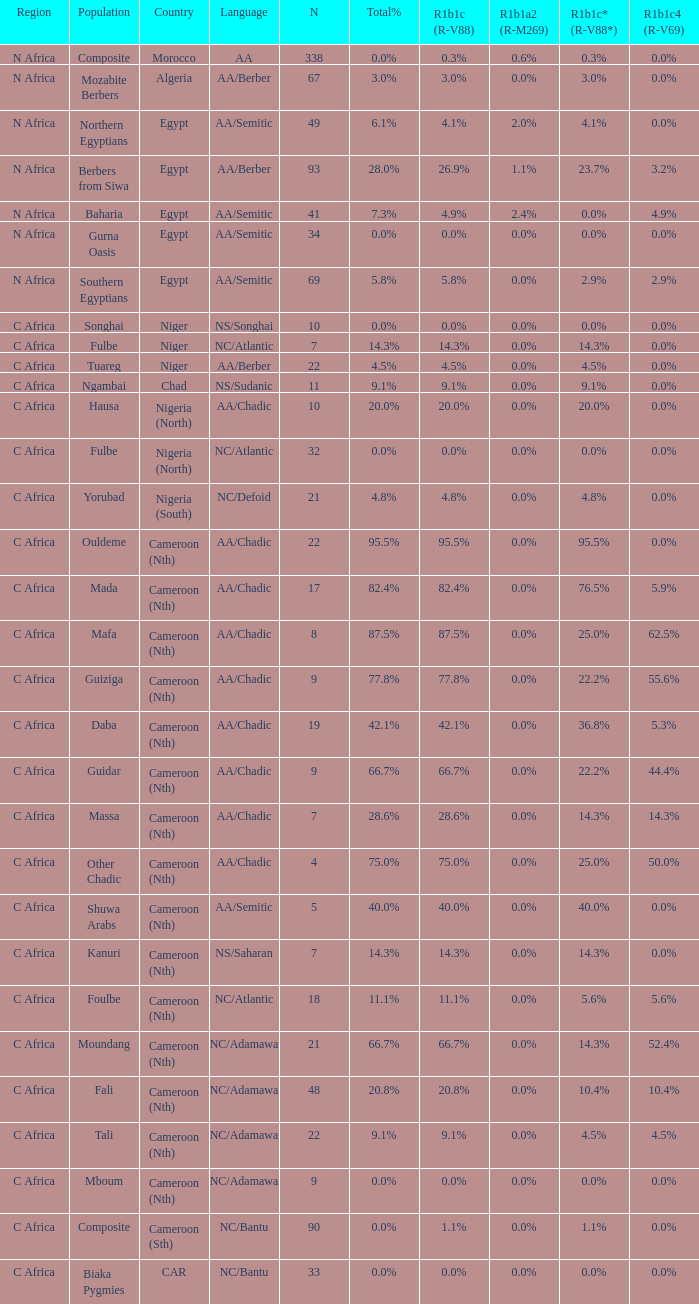How many n are listed for berbers from siwa? 1.0. 